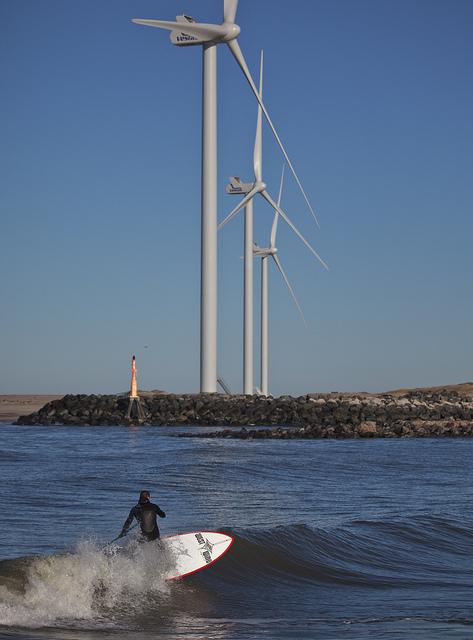How many people are standing on their surfboards?
Short answer required. 1. Do these people appear to be surfing in the open ocean?
Write a very short answer. Yes. Is this water smooth?
Keep it brief. No. Is the surfer wearing a wetsuit?
Short answer required. Yes. What year do you think this photo was taken?
Concise answer only. 2010. What windmills are in the photo?
Keep it brief. 3. Is there a lighthouse in the background?
Write a very short answer. Yes. 